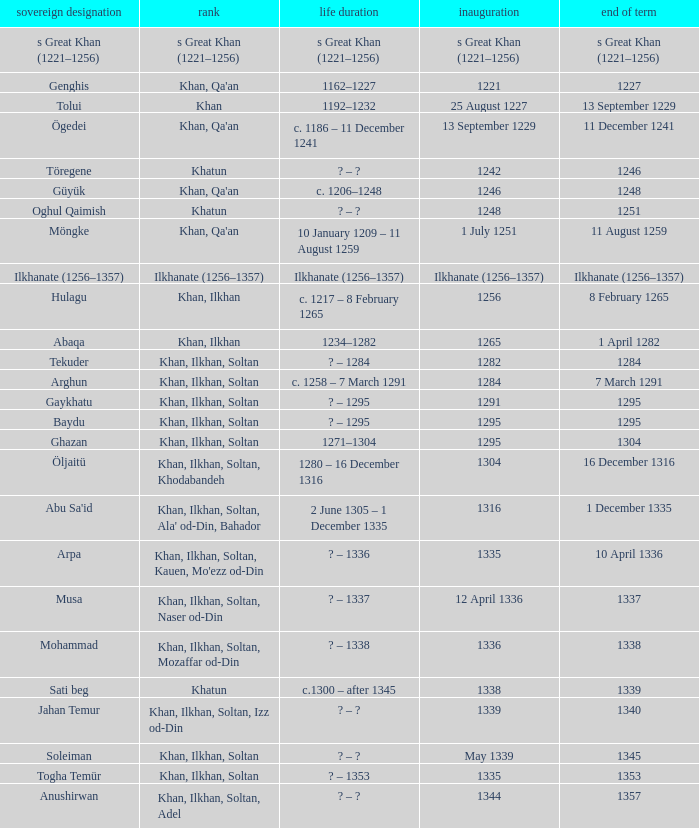What is the born-died that has office of 13 September 1229 as the entered? C. 1186 – 11 december 1241. 